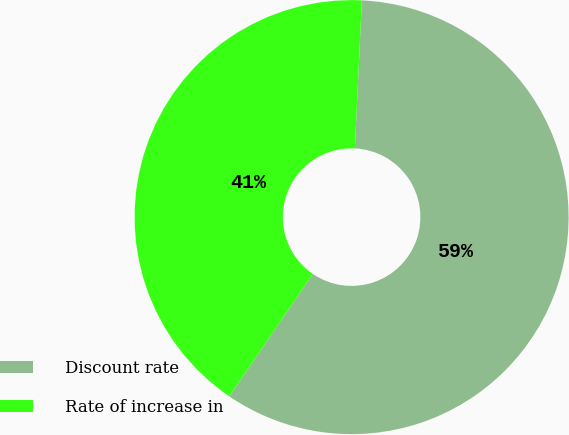Convert chart. <chart><loc_0><loc_0><loc_500><loc_500><pie_chart><fcel>Discount rate<fcel>Rate of increase in<nl><fcel>58.78%<fcel>41.22%<nl></chart> 